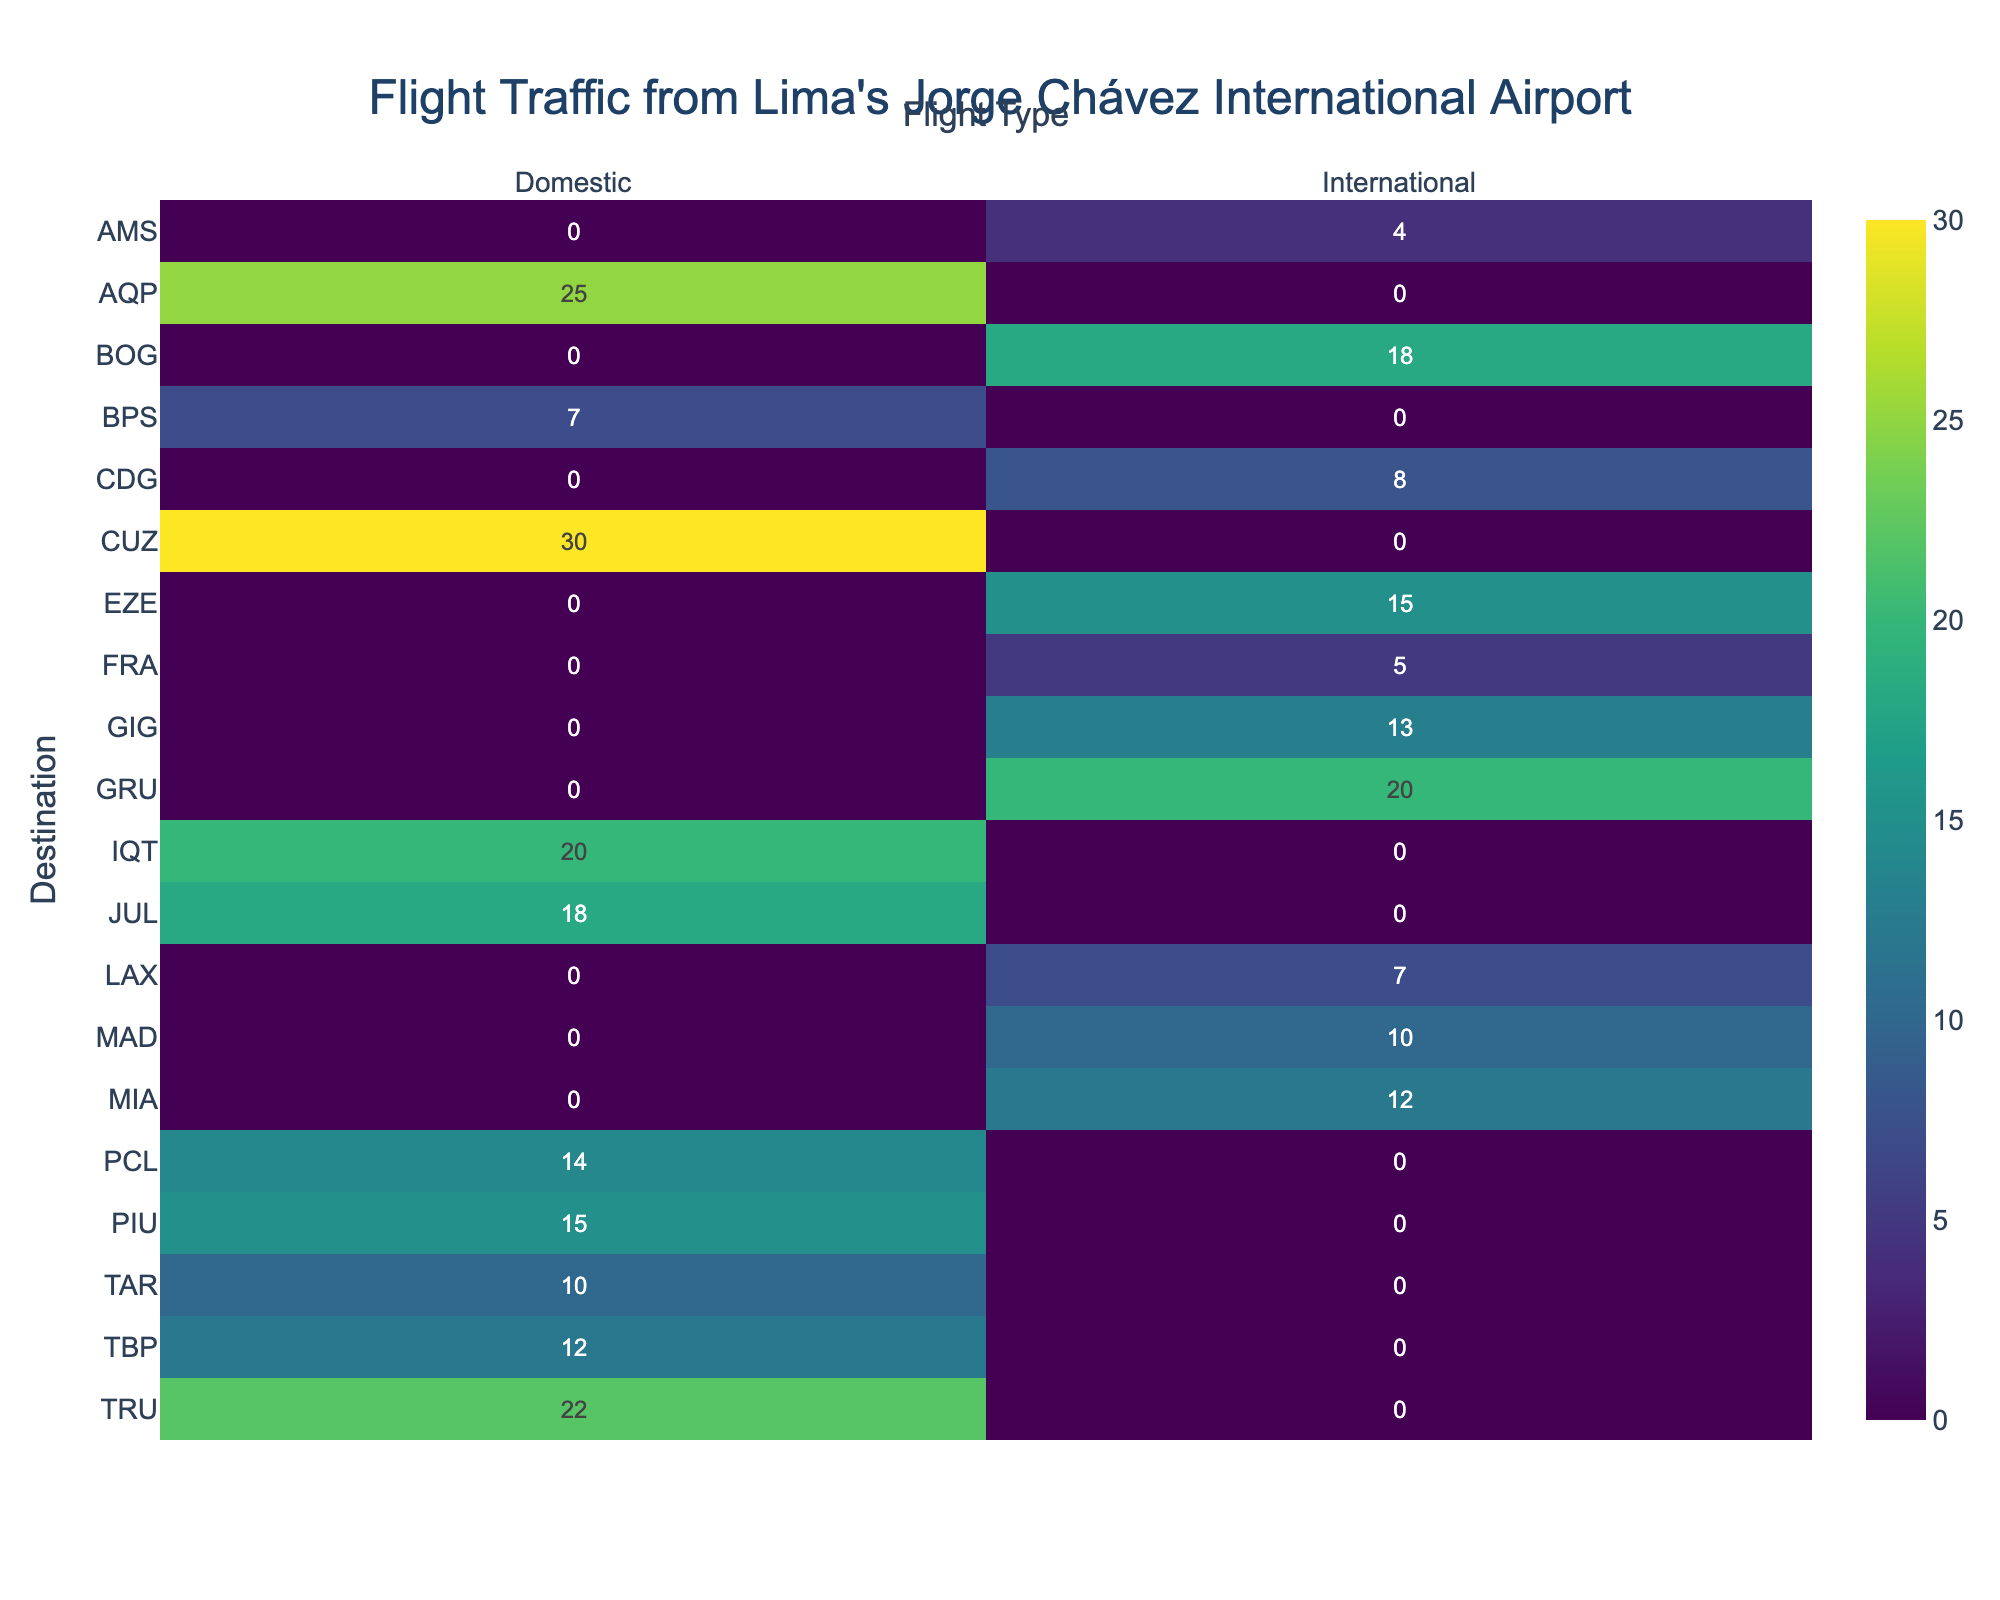What's the most frequent destination for international flights? The heatmap shows the number of daily flights from Lima to various destinations. The cell with the highest value for 'International' flights indicates the most frequent destination. By looking at the heatmap, the destination with the highest number is GRU with 20 daily flights.
Answer: GRU What's the total number of daily domestic flights from Lima? To find the total number of daily domestic flights, sum the values for all destinations under the 'Domestic' column. Adding these values: 30 (CUZ) + 25 (AQP) + 20 (IQT) + 15 (PIU) + 22 (TRU) + 10 (TAR) + 12 (TBP) + 14 (PCL) + 18 (JUL) + 7 (BPS) = 173.
Answer: 173 Which destination has the least number of daily flights for both international and domestic categories? Locate the cells with the lowest values in both the 'International' and 'Domestic' columns. The destination with the lowest number is AMS in international with 4 flights and BPS in domestic with 7 flights.
Answer: AMS for international, BPS for domestic How many more daily domestic flights are there than international flights? First, find the total number of daily domestic and international flights. Total domestic flights: 173. Total international flights: 20 + 15 + 18 + 10 + 12 + 8 + 7 + 5 + 13 + 4 = 112. The difference is 173 - 112 = 61.
Answer: 61 Which flight type has more flights to BOG: international or domestic? Check the number of flights to BOG in both the 'International' and 'Domestic' categories by looking at the corresponding cells in the heatmap. BOG has 18 international flights and 0 domestic flights.
Answer: International Are there any destinations with an equal number of flights for both international and domestic categories? Compare each cell in the 'International' column with the corresponding cell in the 'Domestic' column to see if any values are equal. From the heatmap, no destination has the same number of flights in both categories.
Answer: No What's the average number of daily international flights to each destination from Lima? Calculate the arithmetic mean of the daily international flights by adding the values and dividing by the number of destinations. Total international flights: 112. Number of international destinations: 10. The average is 112 / 10 = 11.2.
Answer: 11.2 Which destination has the highest number of daily flights in total? Add the international and domestic flight counts for each destination, and identify the destination with the highest total. CUZ has the highest with 30 (domestic) + 0 (international) = 30.
Answer: CUZ What's the ratio of daily domestic flights to daily international flights for TRU? Locate the daily flights for TRU under both 'Domestic' and 'International'. TRU has 22 domestic flights and 0 international flights, so the ratio is 22:0. Since it's undefined to divide by zero, the ratio is just noted as 22:0.
Answer: 22:0 